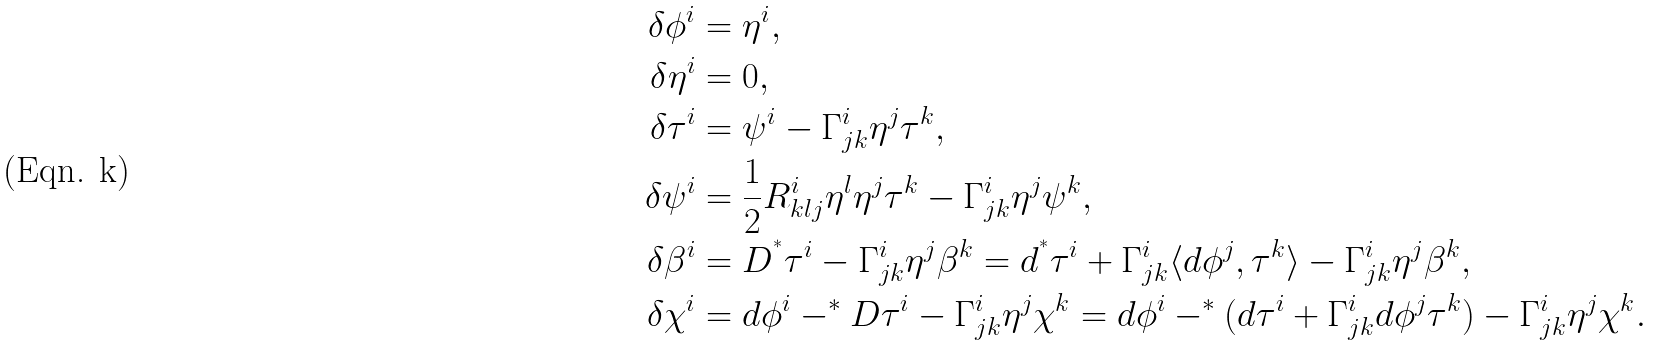<formula> <loc_0><loc_0><loc_500><loc_500>\delta \phi ^ { i } & = \eta ^ { i } , \\ \delta \eta ^ { i } & = 0 , \\ \delta \tau ^ { i } & = \psi ^ { i } - \Gamma ^ { i } _ { j k } \eta ^ { j } \tau ^ { k } , \\ \delta \psi ^ { i } & = \frac { 1 } { 2 } R ^ { i } _ { k l j } \eta ^ { l } \eta ^ { j } \tau ^ { k } - \Gamma ^ { i } _ { j k } \eta ^ { j } \psi ^ { k } , \\ \delta \beta ^ { i } & = D ^ { ^ { * } } \tau ^ { i } - \Gamma ^ { i } _ { j k } \eta ^ { j } \beta ^ { k } = d ^ { ^ { * } } \tau ^ { i } + \Gamma ^ { i } _ { j k } \langle d \phi ^ { j } , \tau ^ { k } \rangle - \Gamma ^ { i } _ { j k } \eta ^ { j } \beta ^ { k } , \\ \delta \chi ^ { i } & = d \phi ^ { i } - ^ { * } D \tau ^ { i } - \Gamma ^ { i } _ { j k } \eta ^ { j } \chi ^ { k } = d \phi ^ { i } - ^ { * } ( d \tau ^ { i } + \Gamma ^ { i } _ { j k } d \phi ^ { j } \tau ^ { k } ) - \Gamma ^ { i } _ { j k } \eta ^ { j } \chi ^ { k } .</formula> 